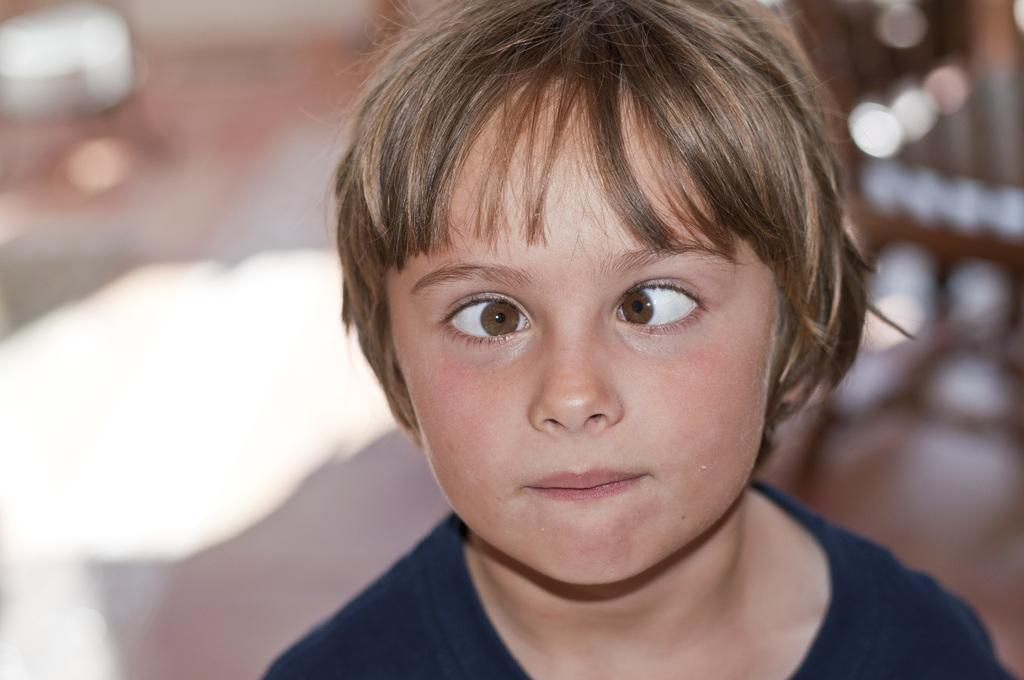What is the main subject of the image? There is a person in the image. What is the person wearing? The person is wearing a black t-shirt. Can you describe the background of the image? The background of the image is blurry. What type of wrench is the person holding in the image? There is no wrench present in the image; the person is not holding any tools. What material is the quiver made of in the image? There is no quiver present in the image; it is not a part of the scene. 